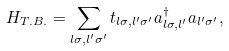Convert formula to latex. <formula><loc_0><loc_0><loc_500><loc_500>H _ { T . B . } = \sum _ { l \sigma , l ^ { \prime } \sigma ^ { \prime } } t _ { l \sigma , l ^ { \prime } \sigma ^ { \prime } } a ^ { \dagger } _ { l \sigma , l ^ { \prime } } a _ { l ^ { \prime } \sigma ^ { \prime } } ,</formula> 